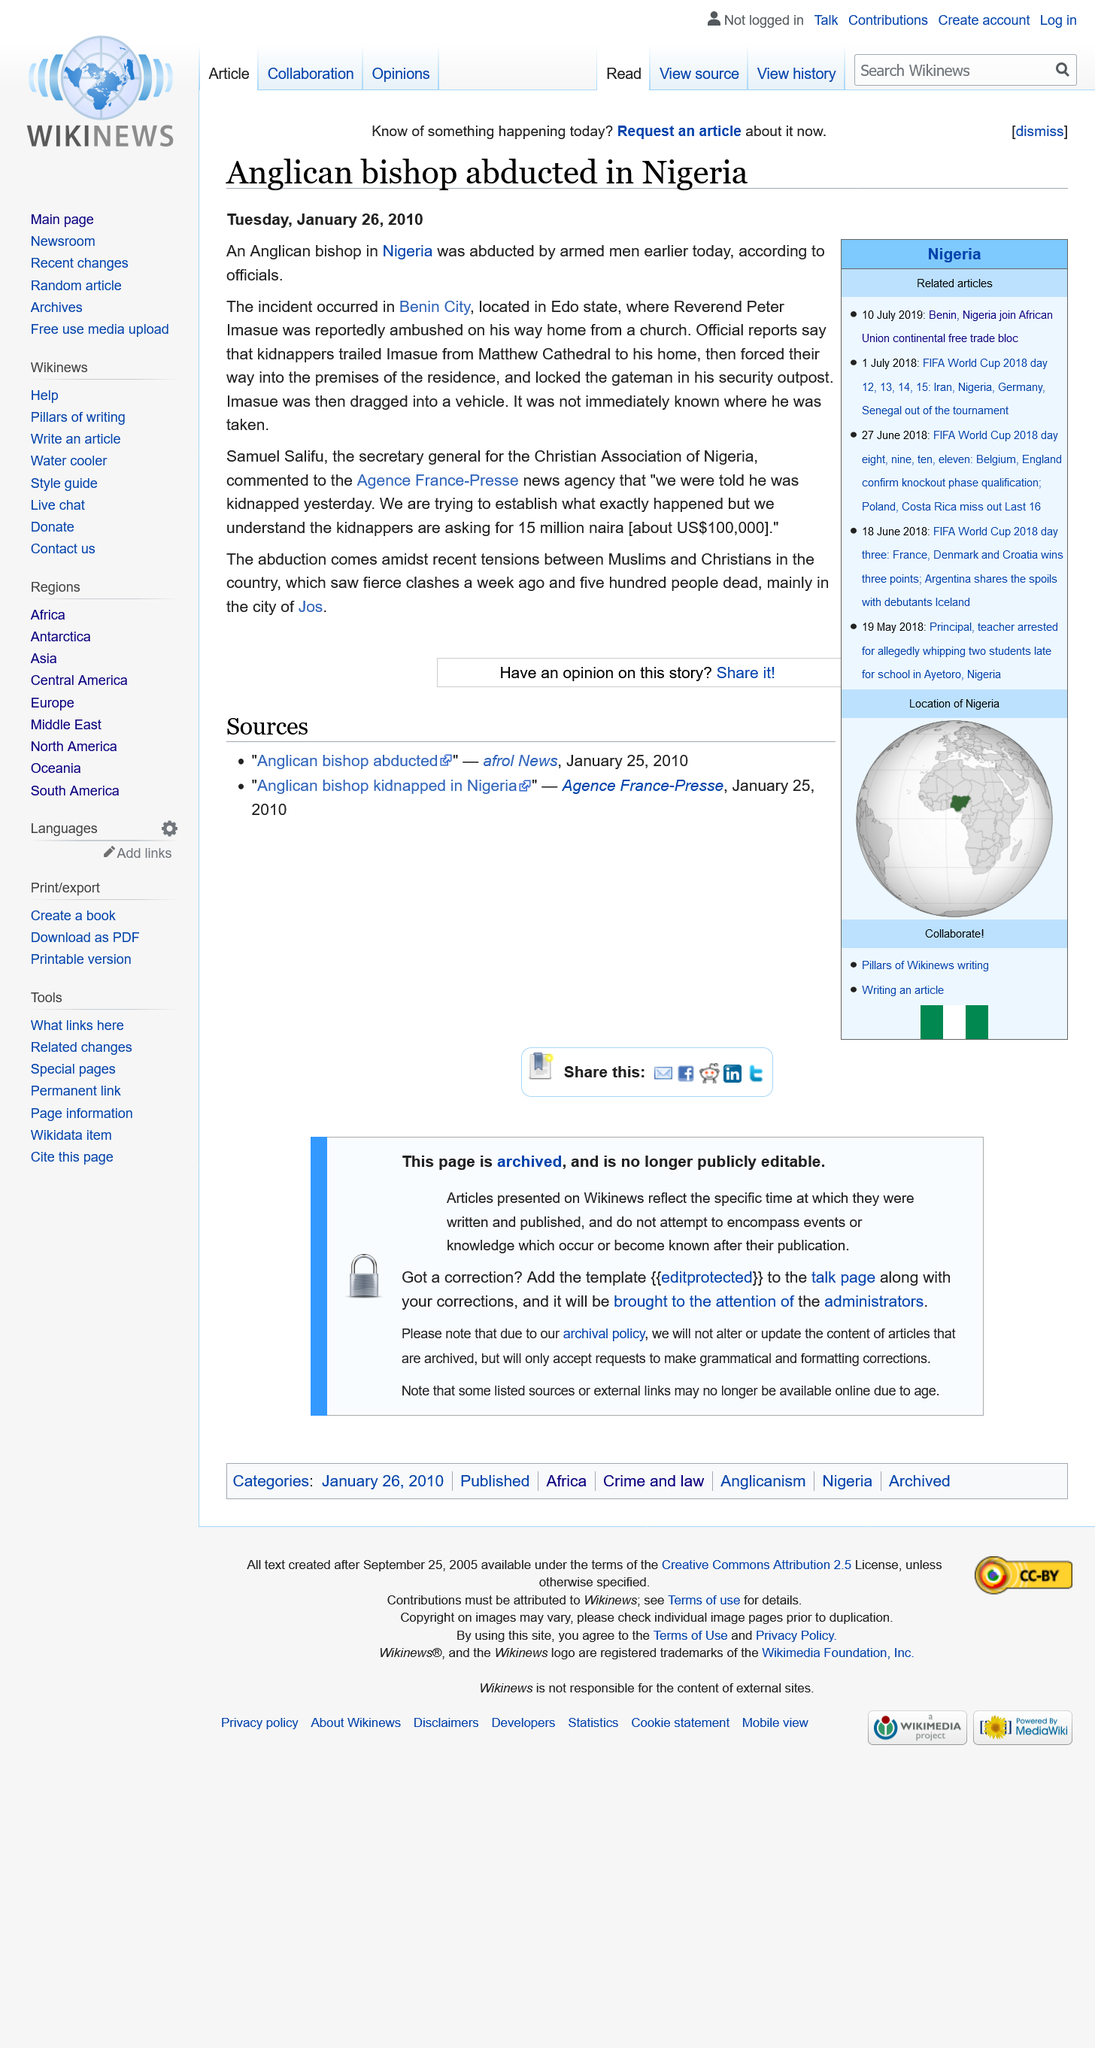Highlight a few significant elements in this photo. This incident occurred in the city of Benin City, located in the country of Nigeria. The Reverend Peter Imasue was abducted, and his name is Reverend Peter Imasue. Samuel Salifu is the current secretary general of the Christian Association of Nigeria. 